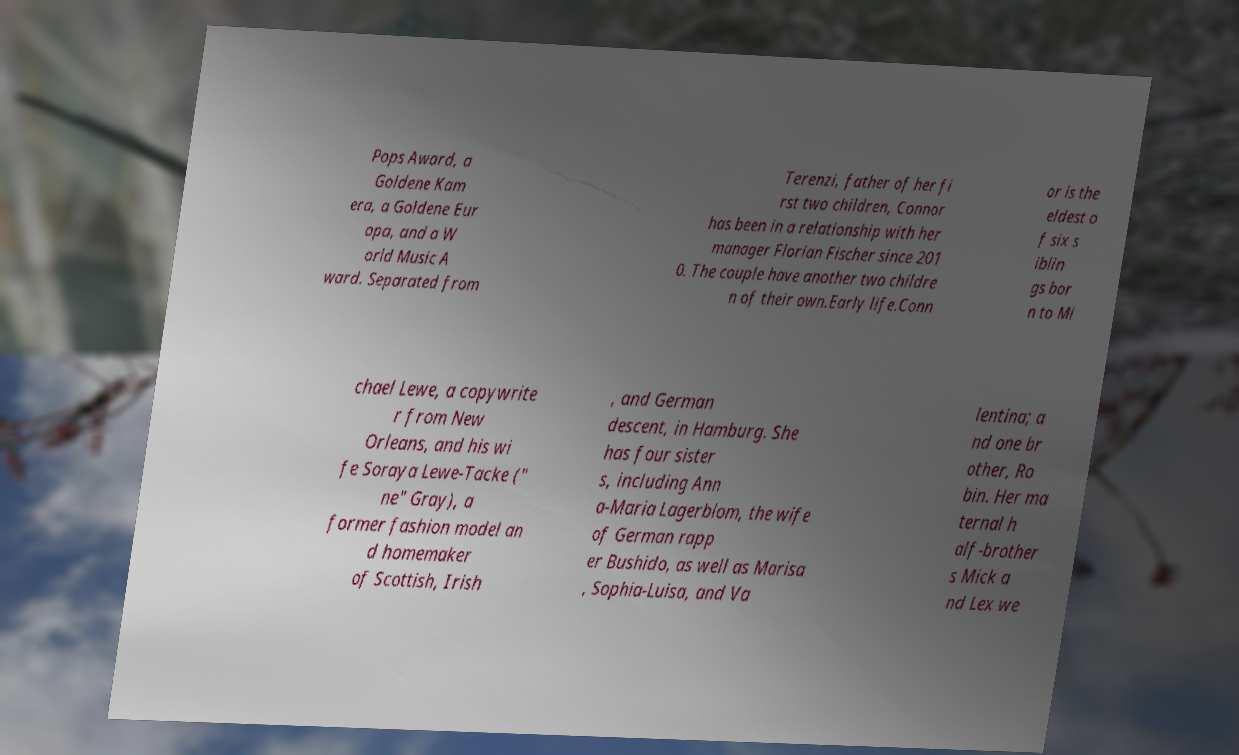Can you read and provide the text displayed in the image?This photo seems to have some interesting text. Can you extract and type it out for me? Pops Award, a Goldene Kam era, a Goldene Eur opa, and a W orld Music A ward. Separated from Terenzi, father of her fi rst two children, Connor has been in a relationship with her manager Florian Fischer since 201 0. The couple have another two childre n of their own.Early life.Conn or is the eldest o f six s iblin gs bor n to Mi chael Lewe, a copywrite r from New Orleans, and his wi fe Soraya Lewe-Tacke (" ne" Gray), a former fashion model an d homemaker of Scottish, Irish , and German descent, in Hamburg. She has four sister s, including Ann a-Maria Lagerblom, the wife of German rapp er Bushido, as well as Marisa , Sophia-Luisa, and Va lentina; a nd one br other, Ro bin. Her ma ternal h alf-brother s Mick a nd Lex we 